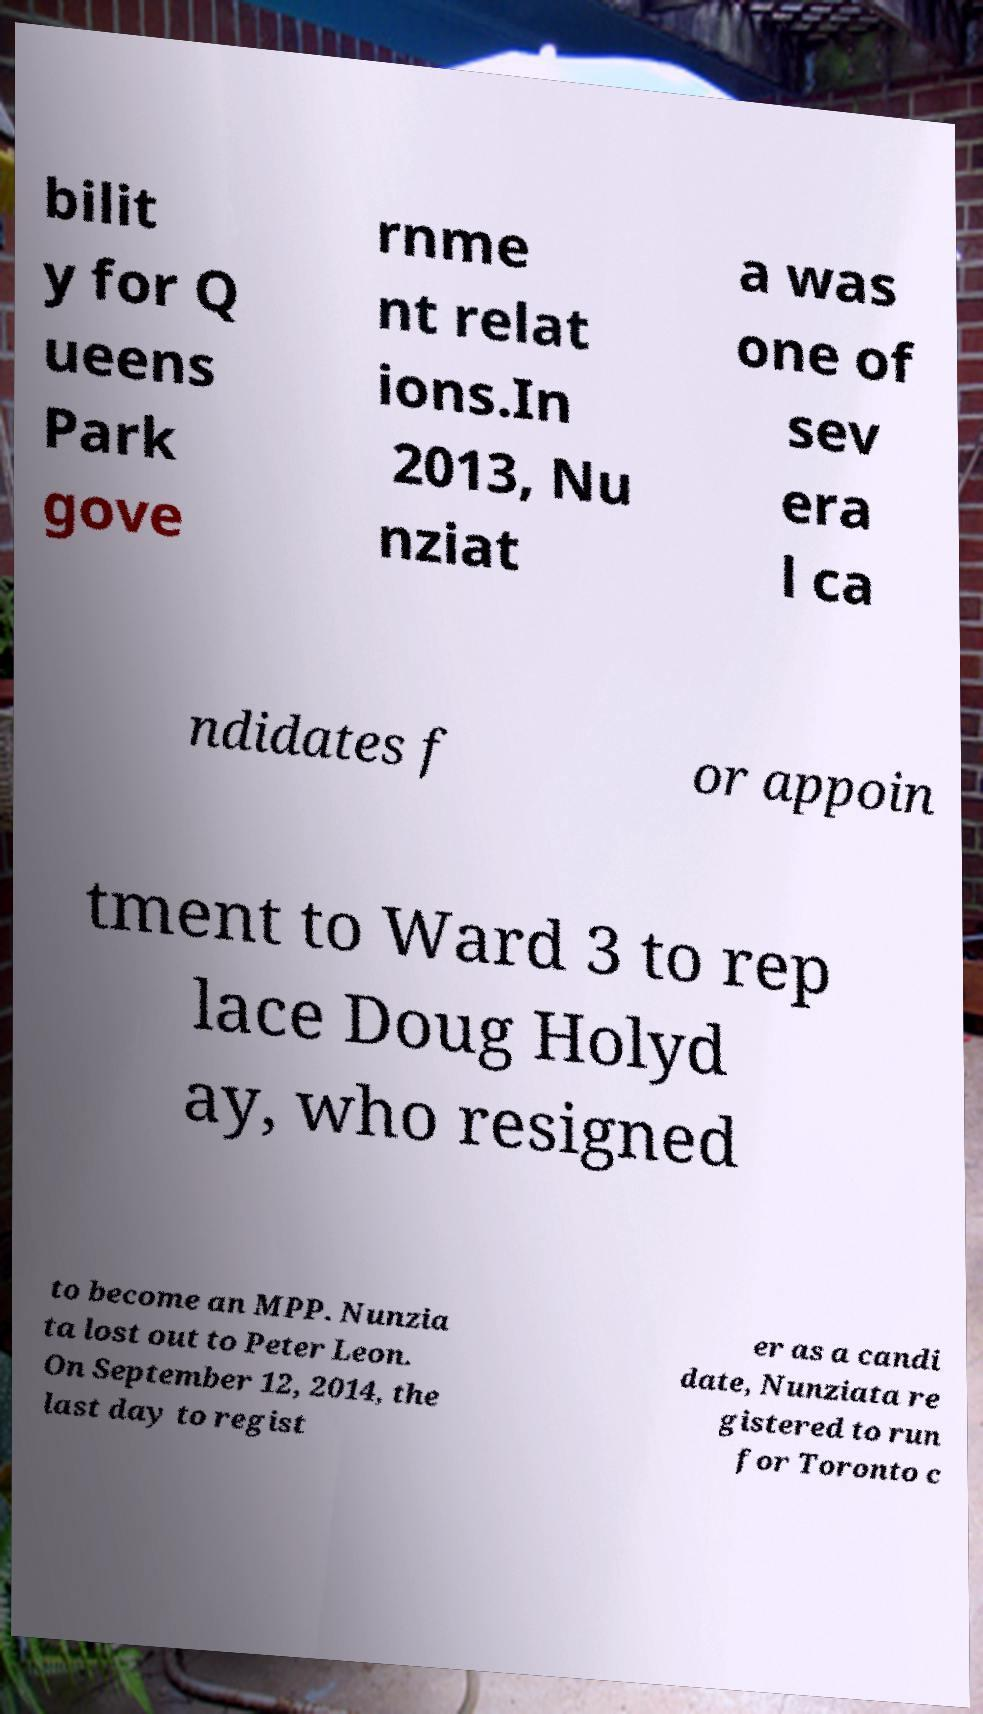Please read and relay the text visible in this image. What does it say? bilit y for Q ueens Park gove rnme nt relat ions.In 2013, Nu nziat a was one of sev era l ca ndidates f or appoin tment to Ward 3 to rep lace Doug Holyd ay, who resigned to become an MPP. Nunzia ta lost out to Peter Leon. On September 12, 2014, the last day to regist er as a candi date, Nunziata re gistered to run for Toronto c 